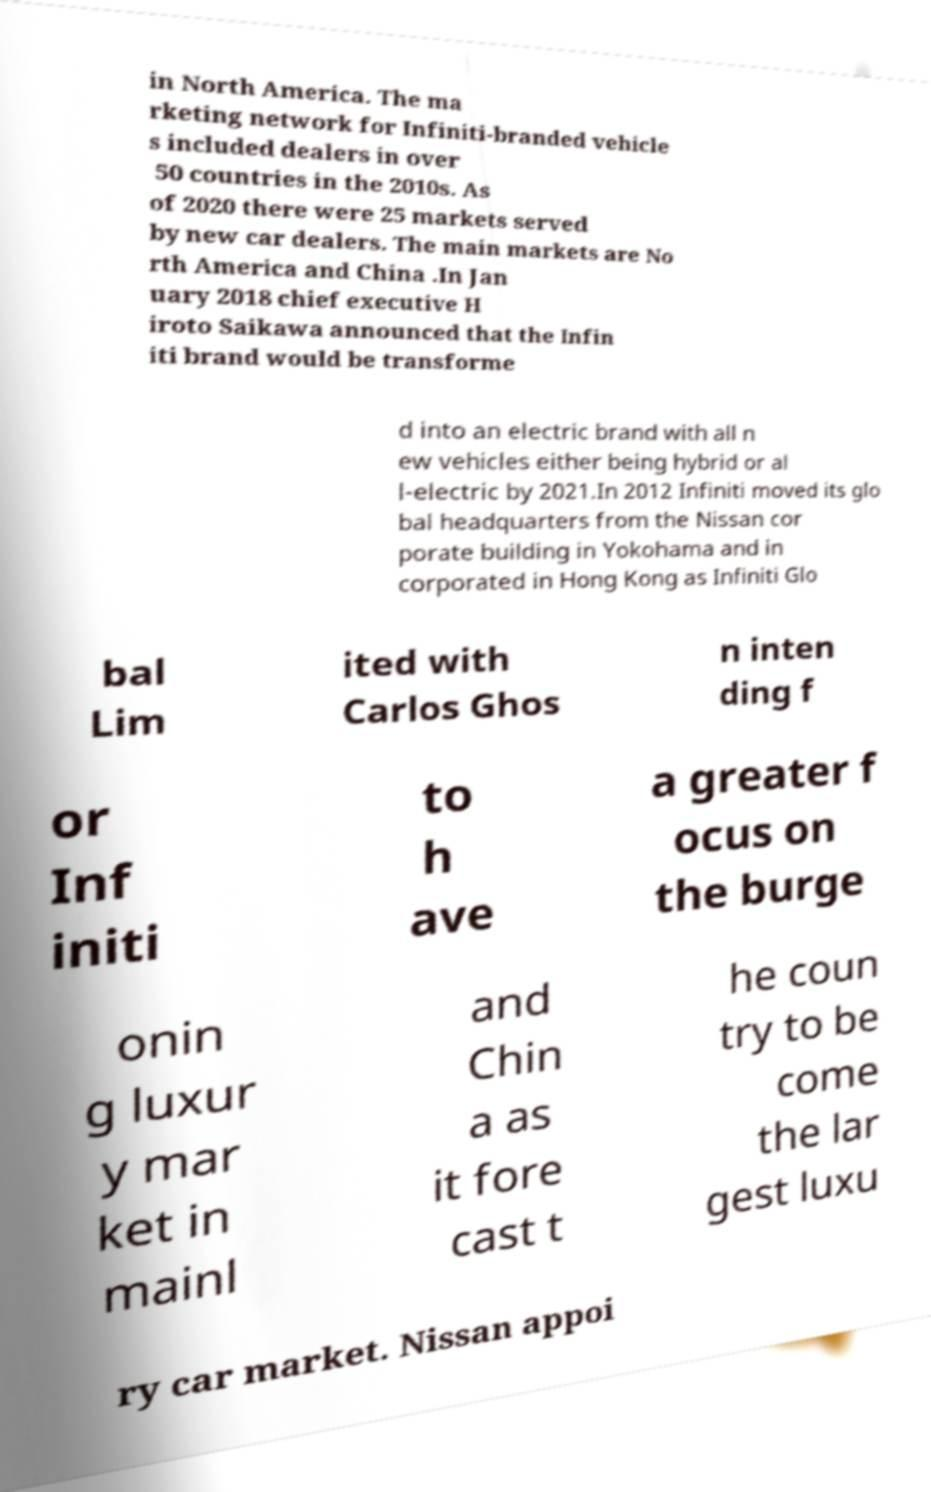Please identify and transcribe the text found in this image. in North America. The ma rketing network for Infiniti-branded vehicle s included dealers in over 50 countries in the 2010s. As of 2020 there were 25 markets served by new car dealers. The main markets are No rth America and China .In Jan uary 2018 chief executive H iroto Saikawa announced that the Infin iti brand would be transforme d into an electric brand with all n ew vehicles either being hybrid or al l-electric by 2021.In 2012 Infiniti moved its glo bal headquarters from the Nissan cor porate building in Yokohama and in corporated in Hong Kong as Infiniti Glo bal Lim ited with Carlos Ghos n inten ding f or Inf initi to h ave a greater f ocus on the burge onin g luxur y mar ket in mainl and Chin a as it fore cast t he coun try to be come the lar gest luxu ry car market. Nissan appoi 